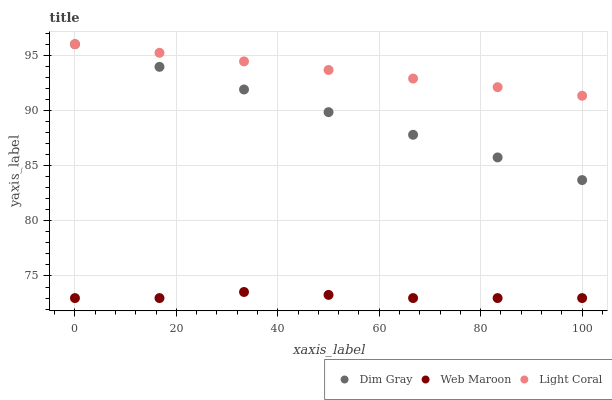Does Web Maroon have the minimum area under the curve?
Answer yes or no. Yes. Does Light Coral have the maximum area under the curve?
Answer yes or no. Yes. Does Dim Gray have the minimum area under the curve?
Answer yes or no. No. Does Dim Gray have the maximum area under the curve?
Answer yes or no. No. Is Dim Gray the smoothest?
Answer yes or no. Yes. Is Web Maroon the roughest?
Answer yes or no. Yes. Is Web Maroon the smoothest?
Answer yes or no. No. Is Dim Gray the roughest?
Answer yes or no. No. Does Web Maroon have the lowest value?
Answer yes or no. Yes. Does Dim Gray have the lowest value?
Answer yes or no. No. Does Dim Gray have the highest value?
Answer yes or no. Yes. Does Web Maroon have the highest value?
Answer yes or no. No. Is Web Maroon less than Light Coral?
Answer yes or no. Yes. Is Light Coral greater than Web Maroon?
Answer yes or no. Yes. Does Dim Gray intersect Light Coral?
Answer yes or no. Yes. Is Dim Gray less than Light Coral?
Answer yes or no. No. Is Dim Gray greater than Light Coral?
Answer yes or no. No. Does Web Maroon intersect Light Coral?
Answer yes or no. No. 